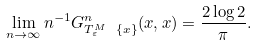Convert formula to latex. <formula><loc_0><loc_0><loc_500><loc_500>\lim _ { n \to \infty } n ^ { - 1 } G ^ { n } _ { T _ { \varepsilon } ^ { M } \ \{ x \} } ( x , x ) = \frac { 2 \log 2 } \pi .</formula> 